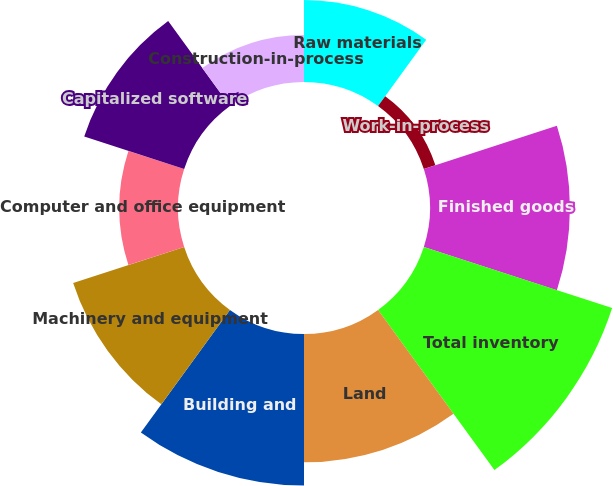Convert chart to OTSL. <chart><loc_0><loc_0><loc_500><loc_500><pie_chart><fcel>Raw materials<fcel>Work-in-process<fcel>Finished goods<fcel>Total inventory<fcel>Land<fcel>Building and<fcel>Machinery and equipment<fcel>Computer and office equipment<fcel>Capitalized software<fcel>Construction-in-process<nl><fcel>7.88%<fcel>1.17%<fcel>13.46%<fcel>19.05%<fcel>12.35%<fcel>14.58%<fcel>11.23%<fcel>5.64%<fcel>10.11%<fcel>4.53%<nl></chart> 